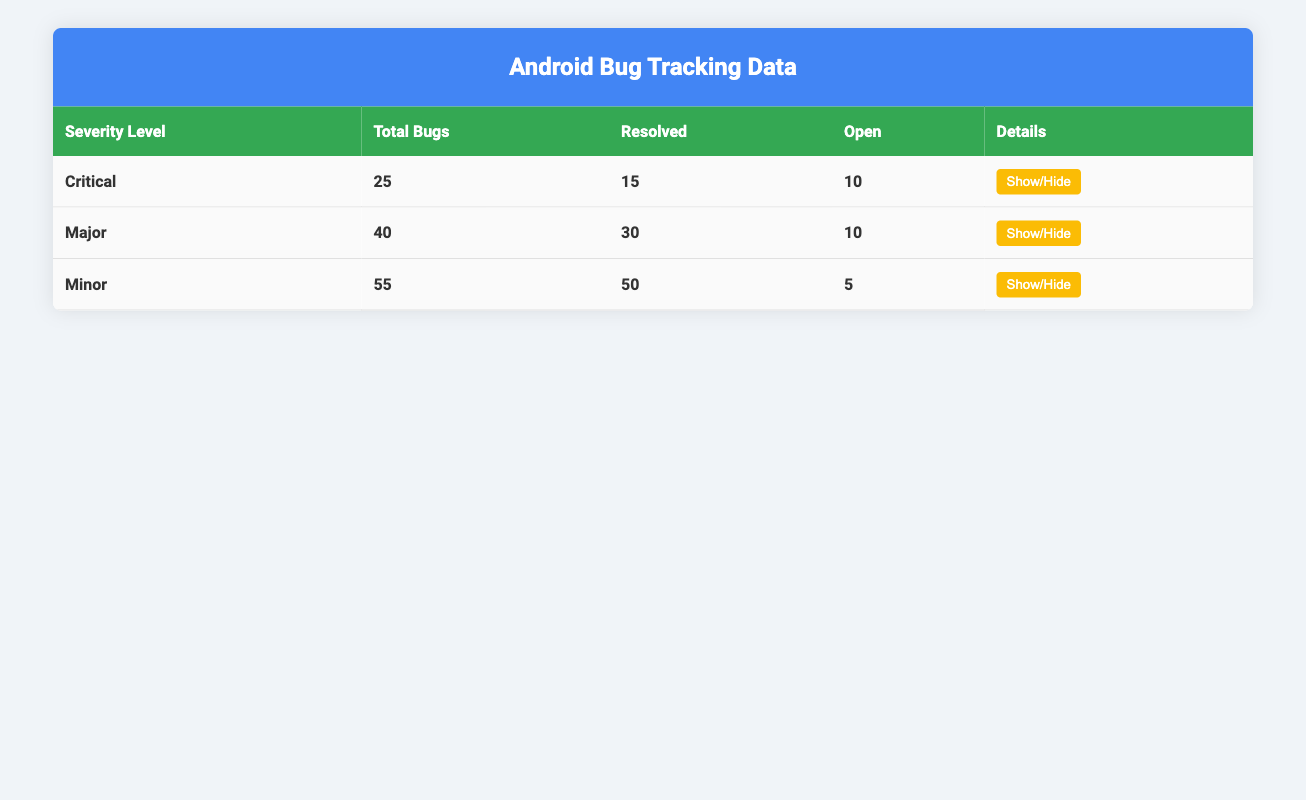What is the total number of critical bugs reported? The table lists the severity levels and their corresponding total bug counts. For critical bugs, the total is directly mentioned in the table as 25.
Answer: 25 How many major bugs are currently open? The table indicates the total number of major bugs as 40, with 30 resolved and 10 open. Therefore, the number of open major bugs is provided as 10.
Answer: 10 Are there any minor bugs that have not been resolved? Looking at the minor section of the table, it shows that there are 5 open bugs, indicating that there are indeed unresolved minor bugs.
Answer: Yes What is the difference between resolved and open bugs for critical severity level? The critical level has 15 resolved bugs and 10 open bugs. The difference can be calculated as 15 (resolved) - 10 (open) = 5.
Answer: 5 What percentage of total bugs across all severity levels have been resolved? First, we sum the total bugs: 25 (Critical) + 40 (Major) + 55 (Minor) = 120. Then, we add the resolved bugs: 15 (Critical) + 30 (Major) + 50 (Minor) = 95. Finally, we calculate the percentage: (95/120) * 100 = 79.17%.
Answer: 79.17% What is the priority of the most recent open bug in critical severity? The most recent open bug in the critical severity, CRIT-102, is described as having critical priority, as indicated in the details provided in the table.
Answer: Critical How many total bugs are resolved across all severity levels? Summing the resolved bugs from each severity level gives us: 15 (Critical) + 30 (Major) + 50 (Minor) = 95. Thus, the total resolved bugs is 95.
Answer: 95 If we consider only the bugs labeled as high priority, how many are open? In the table, the only open bugs indicated as high priority are the following: MAJ-202 (Major) and CRIT-102 (Critical). Therefore, there are 2 high-priority open bugs.
Answer: 2 Which severity level has the highest number of open bugs? By comparing the open bug counts, Critical has 10, Major has 10, and Minor has 5. Both Critical and Major severity levels have 10 open bugs, making them the highest.
Answer: Critical and Major 